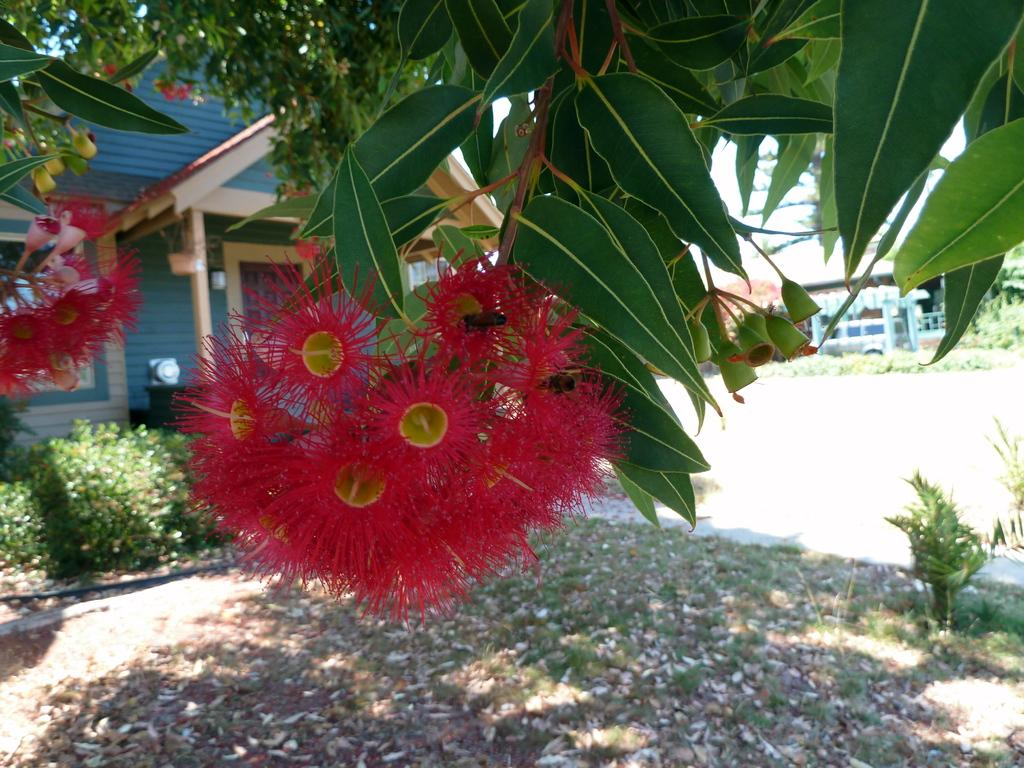What type of plant is in the image? There is a plant with a red flower in the image. Where is the plant located in relation to the image? The plant is in the front of the image. What other structure is visible in the image? There is a building in the image. Where is the building located in relation to the image? The building is in the back of the image. What else can be seen on the land in the image? There are plants in front of the building on the land. Can you tell me how many times the grandmother has visited the dirt in the image? There is no mention of a grandmother or dirt in the image, so it is not possible to answer that question. 